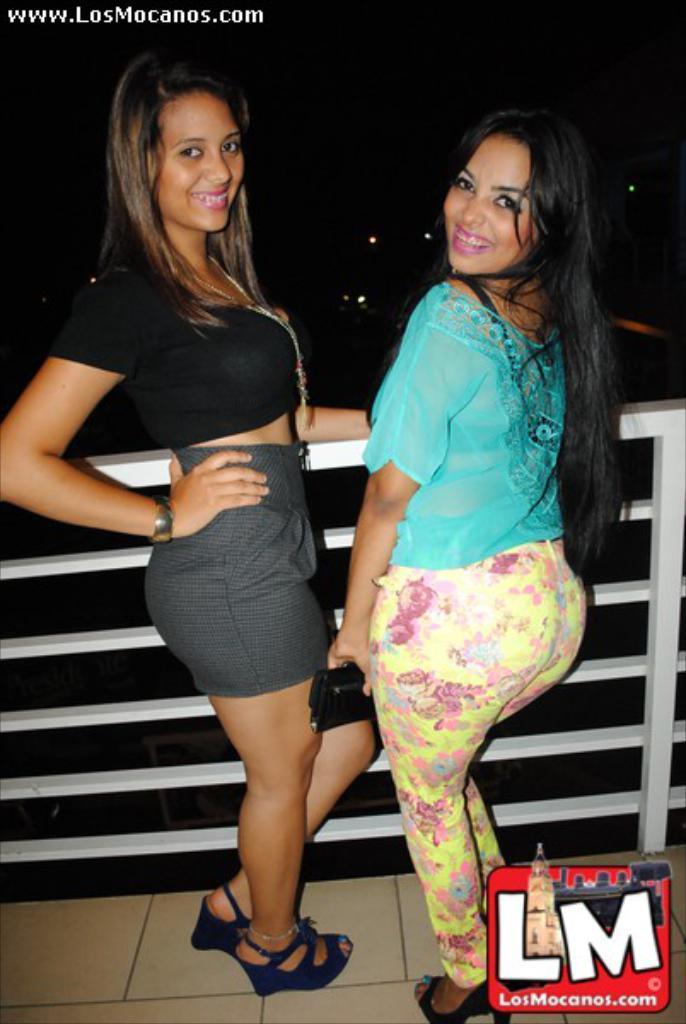How would you summarize this image in a sentence or two? In this image there are two people standing on the floor and they are smiling. In front of them there is a metal fence. In the background of the image there are lights. There is some text at the top of the image. There is a watermark at the bottom of the image. 